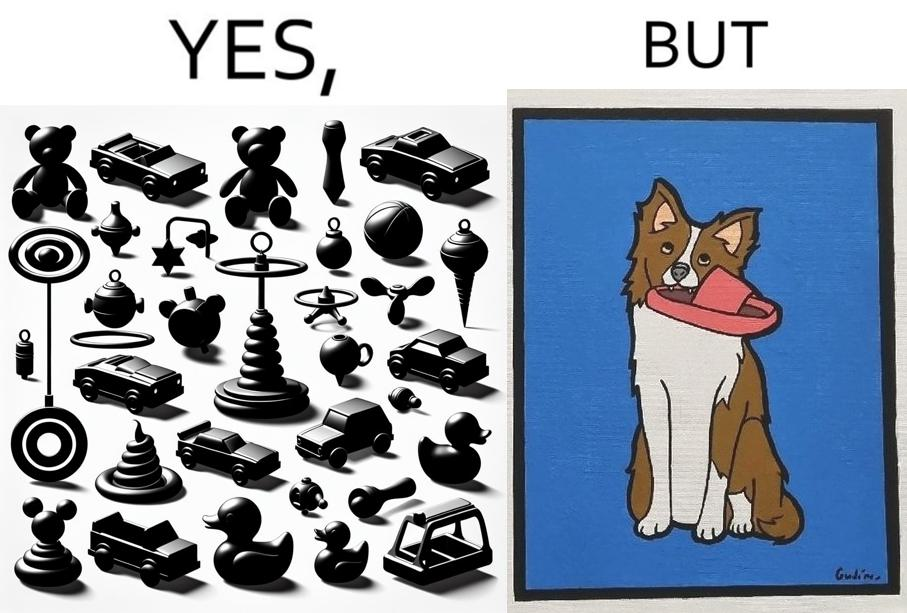Describe the content of this image. the irony is that dog owners buy loads of toys for their dog but the dog's favourite toy is the owner's slippers 